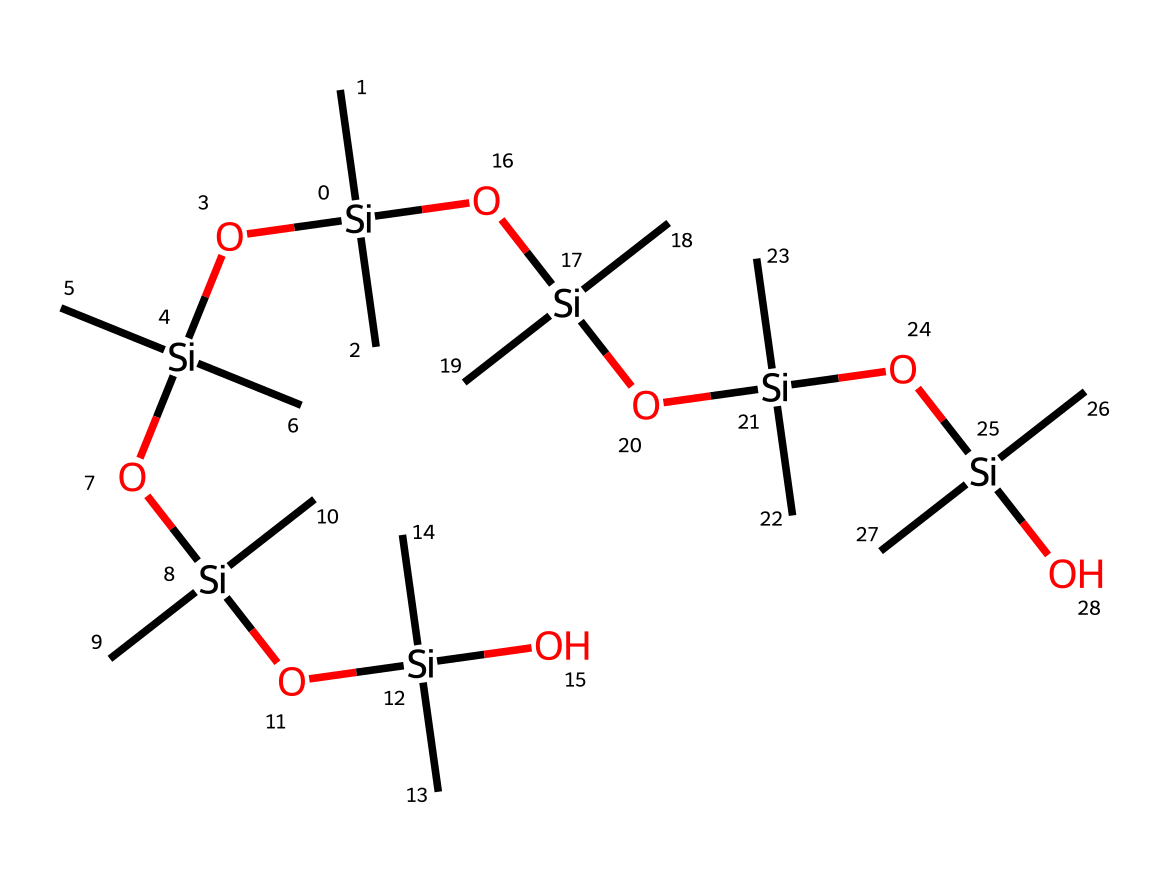how many silicon atoms are present in this structure? By analyzing the SMILES representation, each occurrence of "[Si]" indicates a silicon atom. Counting the occurrences, there are a total of 6 silicon atoms in the structure.
Answer: 6 what is the degree of branching in this organosilicon compound? The structure shows that each silicon atom is attached to two methyl groups and a central silicon atom linked in a chain, indicating a branched structure. The overall arrangement suggests a highly branched polymer.
Answer: highly branched how many oxygen atoms are in this organosilicon compound? Each occurrence of "[O]" in the SMILES indicates an oxygen atom. Counting these, the structure contains 5 oxygen atoms.
Answer: 5 which type of bond predominantly characterizes organosilicon compounds? Organosilicon compounds typically feature Si-C bonds due to the presence of silicon atoms bonded to carbon atoms in the structure. The analysis of the SMILES shows numerous Si-C connections.
Answer: Si-C bond what type of groups are attached to silicon in this structure? The structure clearly shows that each silicon atom is attached to two methyl (C) groups and an oxygen atom. These are characteristic R groups in organosilicon chemistry.
Answer: methyl groups and oxygen how many repetitions of the siloxane unit are in the polymer? The siloxane unit consists of a repeating silicon-oxygen structure; in the SMILES provided, the unit appears 4 times around the central silicon in a branched fashion. This indicates a repeating siloxane unit structure.
Answer: 4 what is the significance of the molecular arrangement in flexible electronics? The flexible arrangement of the organosilicon polymer allows for adaptability and conformability in wearable devices, which require materials that can bend and stretch without losing performance. This structural property promotes electronic device flexibility.
Answer: flexibility and conformability 